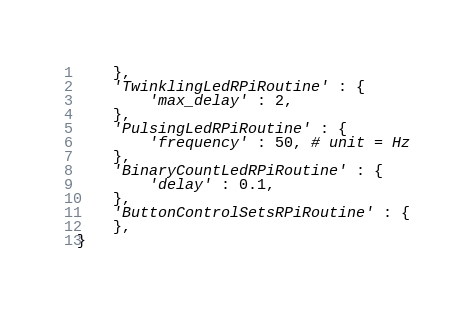Convert code to text. <code><loc_0><loc_0><loc_500><loc_500><_Python_>    },
    'TwinklingLedRPiRoutine' : {
        'max_delay' : 2,
    },
    'PulsingLedRPiRoutine' : {
        'frequency' : 50, # unit = Hz
    },
    'BinaryCountLedRPiRoutine' : {
        'delay' : 0.1,
    },
    'ButtonControlSetsRPiRoutine' : {
    },
}
</code> 